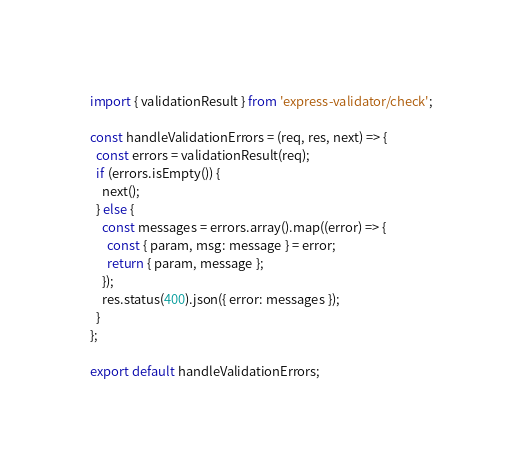Convert code to text. <code><loc_0><loc_0><loc_500><loc_500><_JavaScript_>import { validationResult } from 'express-validator/check';

const handleValidationErrors = (req, res, next) => {
  const errors = validationResult(req);
  if (errors.isEmpty()) {
    next();
  } else {
    const messages = errors.array().map((error) => {
      const { param, msg: message } = error;
      return { param, message };
    });
    res.status(400).json({ error: messages });
  }
};

export default handleValidationErrors;
</code> 